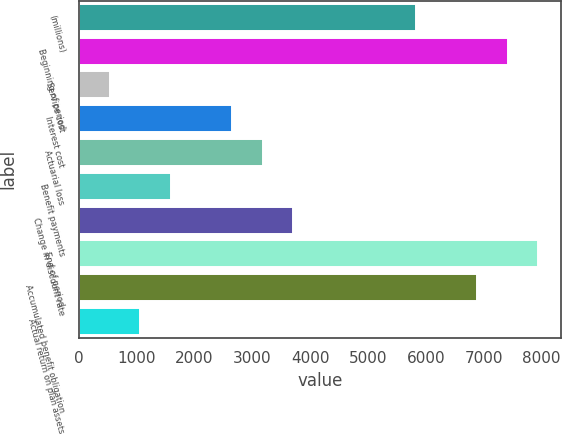<chart> <loc_0><loc_0><loc_500><loc_500><bar_chart><fcel>(millions)<fcel>Beginning of period<fcel>Service cost<fcel>Interest cost<fcel>Actuarial loss<fcel>Benefit payments<fcel>Change in discount rate<fcel>End of period<fcel>Accumulated benefit obligation<fcel>Actual return on plan assets<nl><fcel>5827.3<fcel>7415.2<fcel>534.3<fcel>2651.5<fcel>3180.8<fcel>1592.9<fcel>3710.1<fcel>7944.5<fcel>6885.9<fcel>1063.6<nl></chart> 